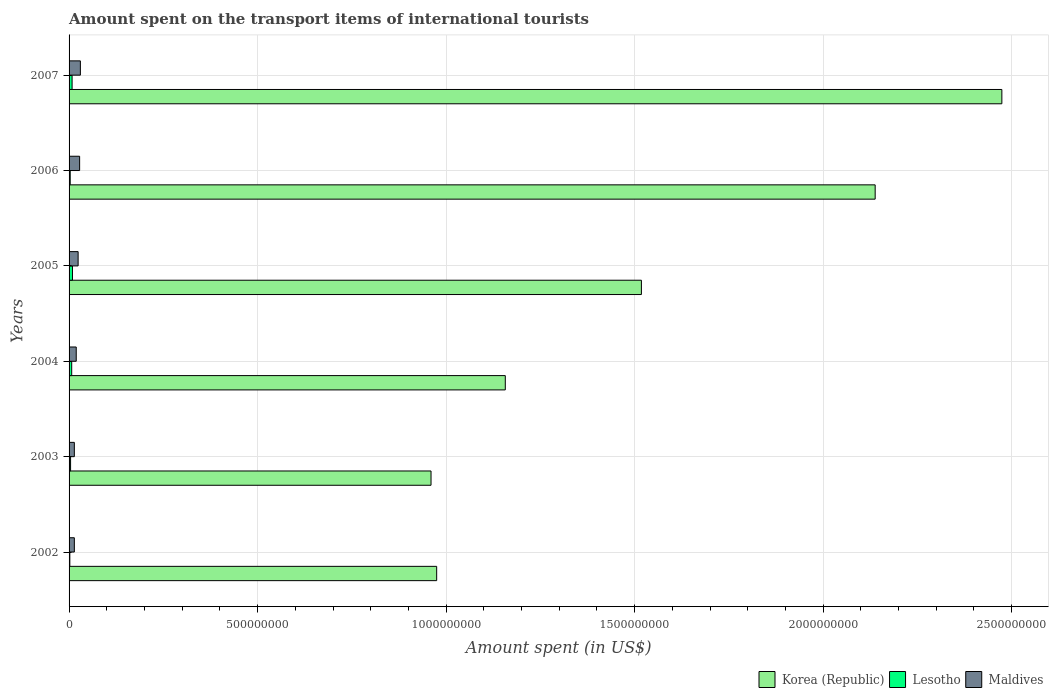How many groups of bars are there?
Ensure brevity in your answer.  6. Are the number of bars per tick equal to the number of legend labels?
Offer a terse response. Yes. How many bars are there on the 6th tick from the bottom?
Give a very brief answer. 3. In how many cases, is the number of bars for a given year not equal to the number of legend labels?
Your answer should be compact. 0. What is the amount spent on the transport items of international tourists in Lesotho in 2006?
Your response must be concise. 3.00e+06. Across all years, what is the maximum amount spent on the transport items of international tourists in Maldives?
Make the answer very short. 3.00e+07. Across all years, what is the minimum amount spent on the transport items of international tourists in Maldives?
Give a very brief answer. 1.40e+07. What is the total amount spent on the transport items of international tourists in Lesotho in the graph?
Ensure brevity in your answer.  3.30e+07. What is the difference between the amount spent on the transport items of international tourists in Maldives in 2004 and that in 2006?
Your answer should be very brief. -9.00e+06. What is the difference between the amount spent on the transport items of international tourists in Maldives in 2006 and the amount spent on the transport items of international tourists in Lesotho in 2002?
Provide a succinct answer. 2.60e+07. What is the average amount spent on the transport items of international tourists in Korea (Republic) per year?
Provide a succinct answer. 1.54e+09. In the year 2005, what is the difference between the amount spent on the transport items of international tourists in Lesotho and amount spent on the transport items of international tourists in Korea (Republic)?
Your answer should be very brief. -1.51e+09. What is the ratio of the amount spent on the transport items of international tourists in Lesotho in 2004 to that in 2005?
Provide a short and direct response. 0.78. Is the difference between the amount spent on the transport items of international tourists in Lesotho in 2004 and 2005 greater than the difference between the amount spent on the transport items of international tourists in Korea (Republic) in 2004 and 2005?
Your answer should be compact. Yes. What is the difference between the highest and the second highest amount spent on the transport items of international tourists in Korea (Republic)?
Make the answer very short. 3.36e+08. What is the difference between the highest and the lowest amount spent on the transport items of international tourists in Korea (Republic)?
Ensure brevity in your answer.  1.51e+09. In how many years, is the amount spent on the transport items of international tourists in Korea (Republic) greater than the average amount spent on the transport items of international tourists in Korea (Republic) taken over all years?
Your response must be concise. 2. Is the sum of the amount spent on the transport items of international tourists in Maldives in 2003 and 2004 greater than the maximum amount spent on the transport items of international tourists in Korea (Republic) across all years?
Give a very brief answer. No. What does the 1st bar from the top in 2005 represents?
Your answer should be very brief. Maldives. What does the 2nd bar from the bottom in 2003 represents?
Your answer should be compact. Lesotho. How many bars are there?
Give a very brief answer. 18. Are all the bars in the graph horizontal?
Your answer should be compact. Yes. How many years are there in the graph?
Your response must be concise. 6. What is the difference between two consecutive major ticks on the X-axis?
Give a very brief answer. 5.00e+08. Does the graph contain grids?
Give a very brief answer. Yes. Where does the legend appear in the graph?
Provide a succinct answer. Bottom right. What is the title of the graph?
Offer a very short reply. Amount spent on the transport items of international tourists. What is the label or title of the X-axis?
Give a very brief answer. Amount spent (in US$). What is the Amount spent (in US$) of Korea (Republic) in 2002?
Your answer should be compact. 9.75e+08. What is the Amount spent (in US$) of Lesotho in 2002?
Ensure brevity in your answer.  2.00e+06. What is the Amount spent (in US$) in Maldives in 2002?
Make the answer very short. 1.40e+07. What is the Amount spent (in US$) in Korea (Republic) in 2003?
Provide a short and direct response. 9.60e+08. What is the Amount spent (in US$) in Lesotho in 2003?
Provide a succinct answer. 4.00e+06. What is the Amount spent (in US$) of Maldives in 2003?
Provide a short and direct response. 1.40e+07. What is the Amount spent (in US$) in Korea (Republic) in 2004?
Your answer should be very brief. 1.16e+09. What is the Amount spent (in US$) in Maldives in 2004?
Your response must be concise. 1.90e+07. What is the Amount spent (in US$) of Korea (Republic) in 2005?
Offer a very short reply. 1.52e+09. What is the Amount spent (in US$) in Lesotho in 2005?
Give a very brief answer. 9.00e+06. What is the Amount spent (in US$) of Maldives in 2005?
Provide a short and direct response. 2.40e+07. What is the Amount spent (in US$) of Korea (Republic) in 2006?
Your answer should be compact. 2.14e+09. What is the Amount spent (in US$) of Maldives in 2006?
Ensure brevity in your answer.  2.80e+07. What is the Amount spent (in US$) of Korea (Republic) in 2007?
Give a very brief answer. 2.47e+09. What is the Amount spent (in US$) of Lesotho in 2007?
Keep it short and to the point. 8.00e+06. What is the Amount spent (in US$) in Maldives in 2007?
Ensure brevity in your answer.  3.00e+07. Across all years, what is the maximum Amount spent (in US$) in Korea (Republic)?
Make the answer very short. 2.47e+09. Across all years, what is the maximum Amount spent (in US$) of Lesotho?
Give a very brief answer. 9.00e+06. Across all years, what is the maximum Amount spent (in US$) in Maldives?
Your response must be concise. 3.00e+07. Across all years, what is the minimum Amount spent (in US$) of Korea (Republic)?
Your answer should be compact. 9.60e+08. Across all years, what is the minimum Amount spent (in US$) of Maldives?
Your response must be concise. 1.40e+07. What is the total Amount spent (in US$) in Korea (Republic) in the graph?
Make the answer very short. 9.22e+09. What is the total Amount spent (in US$) of Lesotho in the graph?
Offer a terse response. 3.30e+07. What is the total Amount spent (in US$) of Maldives in the graph?
Keep it short and to the point. 1.29e+08. What is the difference between the Amount spent (in US$) in Korea (Republic) in 2002 and that in 2003?
Keep it short and to the point. 1.50e+07. What is the difference between the Amount spent (in US$) in Korea (Republic) in 2002 and that in 2004?
Provide a short and direct response. -1.82e+08. What is the difference between the Amount spent (in US$) of Lesotho in 2002 and that in 2004?
Provide a short and direct response. -5.00e+06. What is the difference between the Amount spent (in US$) in Maldives in 2002 and that in 2004?
Give a very brief answer. -5.00e+06. What is the difference between the Amount spent (in US$) in Korea (Republic) in 2002 and that in 2005?
Your response must be concise. -5.43e+08. What is the difference between the Amount spent (in US$) of Lesotho in 2002 and that in 2005?
Make the answer very short. -7.00e+06. What is the difference between the Amount spent (in US$) of Maldives in 2002 and that in 2005?
Make the answer very short. -1.00e+07. What is the difference between the Amount spent (in US$) in Korea (Republic) in 2002 and that in 2006?
Offer a very short reply. -1.16e+09. What is the difference between the Amount spent (in US$) in Lesotho in 2002 and that in 2006?
Your answer should be very brief. -1.00e+06. What is the difference between the Amount spent (in US$) in Maldives in 2002 and that in 2006?
Give a very brief answer. -1.40e+07. What is the difference between the Amount spent (in US$) of Korea (Republic) in 2002 and that in 2007?
Offer a very short reply. -1.50e+09. What is the difference between the Amount spent (in US$) in Lesotho in 2002 and that in 2007?
Provide a short and direct response. -6.00e+06. What is the difference between the Amount spent (in US$) in Maldives in 2002 and that in 2007?
Keep it short and to the point. -1.60e+07. What is the difference between the Amount spent (in US$) in Korea (Republic) in 2003 and that in 2004?
Offer a very short reply. -1.97e+08. What is the difference between the Amount spent (in US$) in Lesotho in 2003 and that in 2004?
Keep it short and to the point. -3.00e+06. What is the difference between the Amount spent (in US$) of Maldives in 2003 and that in 2004?
Ensure brevity in your answer.  -5.00e+06. What is the difference between the Amount spent (in US$) in Korea (Republic) in 2003 and that in 2005?
Give a very brief answer. -5.58e+08. What is the difference between the Amount spent (in US$) in Lesotho in 2003 and that in 2005?
Your response must be concise. -5.00e+06. What is the difference between the Amount spent (in US$) of Maldives in 2003 and that in 2005?
Offer a very short reply. -1.00e+07. What is the difference between the Amount spent (in US$) of Korea (Republic) in 2003 and that in 2006?
Provide a short and direct response. -1.18e+09. What is the difference between the Amount spent (in US$) of Lesotho in 2003 and that in 2006?
Offer a terse response. 1.00e+06. What is the difference between the Amount spent (in US$) of Maldives in 2003 and that in 2006?
Make the answer very short. -1.40e+07. What is the difference between the Amount spent (in US$) in Korea (Republic) in 2003 and that in 2007?
Provide a succinct answer. -1.51e+09. What is the difference between the Amount spent (in US$) of Lesotho in 2003 and that in 2007?
Ensure brevity in your answer.  -4.00e+06. What is the difference between the Amount spent (in US$) in Maldives in 2003 and that in 2007?
Keep it short and to the point. -1.60e+07. What is the difference between the Amount spent (in US$) in Korea (Republic) in 2004 and that in 2005?
Your answer should be very brief. -3.61e+08. What is the difference between the Amount spent (in US$) in Lesotho in 2004 and that in 2005?
Your answer should be very brief. -2.00e+06. What is the difference between the Amount spent (in US$) in Maldives in 2004 and that in 2005?
Give a very brief answer. -5.00e+06. What is the difference between the Amount spent (in US$) in Korea (Republic) in 2004 and that in 2006?
Provide a short and direct response. -9.81e+08. What is the difference between the Amount spent (in US$) in Maldives in 2004 and that in 2006?
Provide a short and direct response. -9.00e+06. What is the difference between the Amount spent (in US$) in Korea (Republic) in 2004 and that in 2007?
Provide a succinct answer. -1.32e+09. What is the difference between the Amount spent (in US$) of Maldives in 2004 and that in 2007?
Ensure brevity in your answer.  -1.10e+07. What is the difference between the Amount spent (in US$) of Korea (Republic) in 2005 and that in 2006?
Your response must be concise. -6.20e+08. What is the difference between the Amount spent (in US$) in Lesotho in 2005 and that in 2006?
Provide a succinct answer. 6.00e+06. What is the difference between the Amount spent (in US$) in Korea (Republic) in 2005 and that in 2007?
Your response must be concise. -9.56e+08. What is the difference between the Amount spent (in US$) of Maldives in 2005 and that in 2007?
Provide a succinct answer. -6.00e+06. What is the difference between the Amount spent (in US$) of Korea (Republic) in 2006 and that in 2007?
Provide a succinct answer. -3.36e+08. What is the difference between the Amount spent (in US$) of Lesotho in 2006 and that in 2007?
Your answer should be very brief. -5.00e+06. What is the difference between the Amount spent (in US$) of Korea (Republic) in 2002 and the Amount spent (in US$) of Lesotho in 2003?
Your response must be concise. 9.71e+08. What is the difference between the Amount spent (in US$) in Korea (Republic) in 2002 and the Amount spent (in US$) in Maldives in 2003?
Your answer should be very brief. 9.61e+08. What is the difference between the Amount spent (in US$) of Lesotho in 2002 and the Amount spent (in US$) of Maldives in 2003?
Make the answer very short. -1.20e+07. What is the difference between the Amount spent (in US$) in Korea (Republic) in 2002 and the Amount spent (in US$) in Lesotho in 2004?
Offer a very short reply. 9.68e+08. What is the difference between the Amount spent (in US$) in Korea (Republic) in 2002 and the Amount spent (in US$) in Maldives in 2004?
Your response must be concise. 9.56e+08. What is the difference between the Amount spent (in US$) in Lesotho in 2002 and the Amount spent (in US$) in Maldives in 2004?
Keep it short and to the point. -1.70e+07. What is the difference between the Amount spent (in US$) in Korea (Republic) in 2002 and the Amount spent (in US$) in Lesotho in 2005?
Your answer should be very brief. 9.66e+08. What is the difference between the Amount spent (in US$) in Korea (Republic) in 2002 and the Amount spent (in US$) in Maldives in 2005?
Keep it short and to the point. 9.51e+08. What is the difference between the Amount spent (in US$) of Lesotho in 2002 and the Amount spent (in US$) of Maldives in 2005?
Your answer should be very brief. -2.20e+07. What is the difference between the Amount spent (in US$) in Korea (Republic) in 2002 and the Amount spent (in US$) in Lesotho in 2006?
Your answer should be very brief. 9.72e+08. What is the difference between the Amount spent (in US$) in Korea (Republic) in 2002 and the Amount spent (in US$) in Maldives in 2006?
Give a very brief answer. 9.47e+08. What is the difference between the Amount spent (in US$) of Lesotho in 2002 and the Amount spent (in US$) of Maldives in 2006?
Ensure brevity in your answer.  -2.60e+07. What is the difference between the Amount spent (in US$) in Korea (Republic) in 2002 and the Amount spent (in US$) in Lesotho in 2007?
Offer a terse response. 9.67e+08. What is the difference between the Amount spent (in US$) of Korea (Republic) in 2002 and the Amount spent (in US$) of Maldives in 2007?
Your response must be concise. 9.45e+08. What is the difference between the Amount spent (in US$) in Lesotho in 2002 and the Amount spent (in US$) in Maldives in 2007?
Give a very brief answer. -2.80e+07. What is the difference between the Amount spent (in US$) of Korea (Republic) in 2003 and the Amount spent (in US$) of Lesotho in 2004?
Provide a succinct answer. 9.53e+08. What is the difference between the Amount spent (in US$) of Korea (Republic) in 2003 and the Amount spent (in US$) of Maldives in 2004?
Your answer should be compact. 9.41e+08. What is the difference between the Amount spent (in US$) in Lesotho in 2003 and the Amount spent (in US$) in Maldives in 2004?
Give a very brief answer. -1.50e+07. What is the difference between the Amount spent (in US$) of Korea (Republic) in 2003 and the Amount spent (in US$) of Lesotho in 2005?
Give a very brief answer. 9.51e+08. What is the difference between the Amount spent (in US$) of Korea (Republic) in 2003 and the Amount spent (in US$) of Maldives in 2005?
Give a very brief answer. 9.36e+08. What is the difference between the Amount spent (in US$) of Lesotho in 2003 and the Amount spent (in US$) of Maldives in 2005?
Offer a terse response. -2.00e+07. What is the difference between the Amount spent (in US$) in Korea (Republic) in 2003 and the Amount spent (in US$) in Lesotho in 2006?
Make the answer very short. 9.57e+08. What is the difference between the Amount spent (in US$) in Korea (Republic) in 2003 and the Amount spent (in US$) in Maldives in 2006?
Your answer should be very brief. 9.32e+08. What is the difference between the Amount spent (in US$) in Lesotho in 2003 and the Amount spent (in US$) in Maldives in 2006?
Keep it short and to the point. -2.40e+07. What is the difference between the Amount spent (in US$) of Korea (Republic) in 2003 and the Amount spent (in US$) of Lesotho in 2007?
Make the answer very short. 9.52e+08. What is the difference between the Amount spent (in US$) in Korea (Republic) in 2003 and the Amount spent (in US$) in Maldives in 2007?
Provide a succinct answer. 9.30e+08. What is the difference between the Amount spent (in US$) of Lesotho in 2003 and the Amount spent (in US$) of Maldives in 2007?
Offer a very short reply. -2.60e+07. What is the difference between the Amount spent (in US$) of Korea (Republic) in 2004 and the Amount spent (in US$) of Lesotho in 2005?
Offer a very short reply. 1.15e+09. What is the difference between the Amount spent (in US$) of Korea (Republic) in 2004 and the Amount spent (in US$) of Maldives in 2005?
Your answer should be compact. 1.13e+09. What is the difference between the Amount spent (in US$) in Lesotho in 2004 and the Amount spent (in US$) in Maldives in 2005?
Provide a short and direct response. -1.70e+07. What is the difference between the Amount spent (in US$) in Korea (Republic) in 2004 and the Amount spent (in US$) in Lesotho in 2006?
Your answer should be very brief. 1.15e+09. What is the difference between the Amount spent (in US$) in Korea (Republic) in 2004 and the Amount spent (in US$) in Maldives in 2006?
Offer a terse response. 1.13e+09. What is the difference between the Amount spent (in US$) in Lesotho in 2004 and the Amount spent (in US$) in Maldives in 2006?
Your answer should be compact. -2.10e+07. What is the difference between the Amount spent (in US$) of Korea (Republic) in 2004 and the Amount spent (in US$) of Lesotho in 2007?
Your answer should be compact. 1.15e+09. What is the difference between the Amount spent (in US$) of Korea (Republic) in 2004 and the Amount spent (in US$) of Maldives in 2007?
Offer a terse response. 1.13e+09. What is the difference between the Amount spent (in US$) of Lesotho in 2004 and the Amount spent (in US$) of Maldives in 2007?
Your answer should be compact. -2.30e+07. What is the difference between the Amount spent (in US$) in Korea (Republic) in 2005 and the Amount spent (in US$) in Lesotho in 2006?
Make the answer very short. 1.52e+09. What is the difference between the Amount spent (in US$) of Korea (Republic) in 2005 and the Amount spent (in US$) of Maldives in 2006?
Your answer should be very brief. 1.49e+09. What is the difference between the Amount spent (in US$) of Lesotho in 2005 and the Amount spent (in US$) of Maldives in 2006?
Your response must be concise. -1.90e+07. What is the difference between the Amount spent (in US$) in Korea (Republic) in 2005 and the Amount spent (in US$) in Lesotho in 2007?
Ensure brevity in your answer.  1.51e+09. What is the difference between the Amount spent (in US$) of Korea (Republic) in 2005 and the Amount spent (in US$) of Maldives in 2007?
Offer a terse response. 1.49e+09. What is the difference between the Amount spent (in US$) in Lesotho in 2005 and the Amount spent (in US$) in Maldives in 2007?
Ensure brevity in your answer.  -2.10e+07. What is the difference between the Amount spent (in US$) of Korea (Republic) in 2006 and the Amount spent (in US$) of Lesotho in 2007?
Provide a short and direct response. 2.13e+09. What is the difference between the Amount spent (in US$) of Korea (Republic) in 2006 and the Amount spent (in US$) of Maldives in 2007?
Give a very brief answer. 2.11e+09. What is the difference between the Amount spent (in US$) in Lesotho in 2006 and the Amount spent (in US$) in Maldives in 2007?
Provide a short and direct response. -2.70e+07. What is the average Amount spent (in US$) in Korea (Republic) per year?
Provide a succinct answer. 1.54e+09. What is the average Amount spent (in US$) of Lesotho per year?
Your answer should be very brief. 5.50e+06. What is the average Amount spent (in US$) of Maldives per year?
Provide a succinct answer. 2.15e+07. In the year 2002, what is the difference between the Amount spent (in US$) of Korea (Republic) and Amount spent (in US$) of Lesotho?
Make the answer very short. 9.73e+08. In the year 2002, what is the difference between the Amount spent (in US$) of Korea (Republic) and Amount spent (in US$) of Maldives?
Give a very brief answer. 9.61e+08. In the year 2002, what is the difference between the Amount spent (in US$) of Lesotho and Amount spent (in US$) of Maldives?
Offer a terse response. -1.20e+07. In the year 2003, what is the difference between the Amount spent (in US$) of Korea (Republic) and Amount spent (in US$) of Lesotho?
Ensure brevity in your answer.  9.56e+08. In the year 2003, what is the difference between the Amount spent (in US$) in Korea (Republic) and Amount spent (in US$) in Maldives?
Give a very brief answer. 9.46e+08. In the year 2003, what is the difference between the Amount spent (in US$) in Lesotho and Amount spent (in US$) in Maldives?
Provide a succinct answer. -1.00e+07. In the year 2004, what is the difference between the Amount spent (in US$) of Korea (Republic) and Amount spent (in US$) of Lesotho?
Your answer should be very brief. 1.15e+09. In the year 2004, what is the difference between the Amount spent (in US$) in Korea (Republic) and Amount spent (in US$) in Maldives?
Provide a succinct answer. 1.14e+09. In the year 2004, what is the difference between the Amount spent (in US$) of Lesotho and Amount spent (in US$) of Maldives?
Offer a very short reply. -1.20e+07. In the year 2005, what is the difference between the Amount spent (in US$) of Korea (Republic) and Amount spent (in US$) of Lesotho?
Give a very brief answer. 1.51e+09. In the year 2005, what is the difference between the Amount spent (in US$) of Korea (Republic) and Amount spent (in US$) of Maldives?
Your answer should be very brief. 1.49e+09. In the year 2005, what is the difference between the Amount spent (in US$) of Lesotho and Amount spent (in US$) of Maldives?
Offer a terse response. -1.50e+07. In the year 2006, what is the difference between the Amount spent (in US$) in Korea (Republic) and Amount spent (in US$) in Lesotho?
Your answer should be very brief. 2.14e+09. In the year 2006, what is the difference between the Amount spent (in US$) of Korea (Republic) and Amount spent (in US$) of Maldives?
Your answer should be compact. 2.11e+09. In the year 2006, what is the difference between the Amount spent (in US$) in Lesotho and Amount spent (in US$) in Maldives?
Offer a very short reply. -2.50e+07. In the year 2007, what is the difference between the Amount spent (in US$) in Korea (Republic) and Amount spent (in US$) in Lesotho?
Offer a terse response. 2.47e+09. In the year 2007, what is the difference between the Amount spent (in US$) in Korea (Republic) and Amount spent (in US$) in Maldives?
Make the answer very short. 2.44e+09. In the year 2007, what is the difference between the Amount spent (in US$) in Lesotho and Amount spent (in US$) in Maldives?
Your answer should be very brief. -2.20e+07. What is the ratio of the Amount spent (in US$) of Korea (Republic) in 2002 to that in 2003?
Your answer should be compact. 1.02. What is the ratio of the Amount spent (in US$) in Lesotho in 2002 to that in 2003?
Offer a very short reply. 0.5. What is the ratio of the Amount spent (in US$) of Korea (Republic) in 2002 to that in 2004?
Make the answer very short. 0.84. What is the ratio of the Amount spent (in US$) of Lesotho in 2002 to that in 2004?
Provide a short and direct response. 0.29. What is the ratio of the Amount spent (in US$) in Maldives in 2002 to that in 2004?
Give a very brief answer. 0.74. What is the ratio of the Amount spent (in US$) in Korea (Republic) in 2002 to that in 2005?
Your response must be concise. 0.64. What is the ratio of the Amount spent (in US$) in Lesotho in 2002 to that in 2005?
Give a very brief answer. 0.22. What is the ratio of the Amount spent (in US$) of Maldives in 2002 to that in 2005?
Ensure brevity in your answer.  0.58. What is the ratio of the Amount spent (in US$) of Korea (Republic) in 2002 to that in 2006?
Offer a very short reply. 0.46. What is the ratio of the Amount spent (in US$) of Maldives in 2002 to that in 2006?
Your response must be concise. 0.5. What is the ratio of the Amount spent (in US$) of Korea (Republic) in 2002 to that in 2007?
Your answer should be very brief. 0.39. What is the ratio of the Amount spent (in US$) of Lesotho in 2002 to that in 2007?
Provide a short and direct response. 0.25. What is the ratio of the Amount spent (in US$) in Maldives in 2002 to that in 2007?
Ensure brevity in your answer.  0.47. What is the ratio of the Amount spent (in US$) in Korea (Republic) in 2003 to that in 2004?
Keep it short and to the point. 0.83. What is the ratio of the Amount spent (in US$) in Maldives in 2003 to that in 2004?
Your answer should be compact. 0.74. What is the ratio of the Amount spent (in US$) of Korea (Republic) in 2003 to that in 2005?
Provide a short and direct response. 0.63. What is the ratio of the Amount spent (in US$) of Lesotho in 2003 to that in 2005?
Offer a very short reply. 0.44. What is the ratio of the Amount spent (in US$) in Maldives in 2003 to that in 2005?
Your response must be concise. 0.58. What is the ratio of the Amount spent (in US$) in Korea (Republic) in 2003 to that in 2006?
Offer a terse response. 0.45. What is the ratio of the Amount spent (in US$) of Lesotho in 2003 to that in 2006?
Keep it short and to the point. 1.33. What is the ratio of the Amount spent (in US$) in Maldives in 2003 to that in 2006?
Ensure brevity in your answer.  0.5. What is the ratio of the Amount spent (in US$) in Korea (Republic) in 2003 to that in 2007?
Provide a short and direct response. 0.39. What is the ratio of the Amount spent (in US$) of Maldives in 2003 to that in 2007?
Your response must be concise. 0.47. What is the ratio of the Amount spent (in US$) in Korea (Republic) in 2004 to that in 2005?
Your answer should be very brief. 0.76. What is the ratio of the Amount spent (in US$) of Maldives in 2004 to that in 2005?
Keep it short and to the point. 0.79. What is the ratio of the Amount spent (in US$) in Korea (Republic) in 2004 to that in 2006?
Make the answer very short. 0.54. What is the ratio of the Amount spent (in US$) in Lesotho in 2004 to that in 2006?
Offer a terse response. 2.33. What is the ratio of the Amount spent (in US$) of Maldives in 2004 to that in 2006?
Your answer should be compact. 0.68. What is the ratio of the Amount spent (in US$) of Korea (Republic) in 2004 to that in 2007?
Keep it short and to the point. 0.47. What is the ratio of the Amount spent (in US$) of Lesotho in 2004 to that in 2007?
Ensure brevity in your answer.  0.88. What is the ratio of the Amount spent (in US$) of Maldives in 2004 to that in 2007?
Make the answer very short. 0.63. What is the ratio of the Amount spent (in US$) of Korea (Republic) in 2005 to that in 2006?
Ensure brevity in your answer.  0.71. What is the ratio of the Amount spent (in US$) in Lesotho in 2005 to that in 2006?
Provide a succinct answer. 3. What is the ratio of the Amount spent (in US$) in Korea (Republic) in 2005 to that in 2007?
Make the answer very short. 0.61. What is the ratio of the Amount spent (in US$) in Lesotho in 2005 to that in 2007?
Give a very brief answer. 1.12. What is the ratio of the Amount spent (in US$) in Korea (Republic) in 2006 to that in 2007?
Give a very brief answer. 0.86. What is the ratio of the Amount spent (in US$) of Maldives in 2006 to that in 2007?
Make the answer very short. 0.93. What is the difference between the highest and the second highest Amount spent (in US$) in Korea (Republic)?
Offer a very short reply. 3.36e+08. What is the difference between the highest and the second highest Amount spent (in US$) in Lesotho?
Keep it short and to the point. 1.00e+06. What is the difference between the highest and the second highest Amount spent (in US$) in Maldives?
Offer a terse response. 2.00e+06. What is the difference between the highest and the lowest Amount spent (in US$) in Korea (Republic)?
Make the answer very short. 1.51e+09. What is the difference between the highest and the lowest Amount spent (in US$) in Maldives?
Provide a short and direct response. 1.60e+07. 